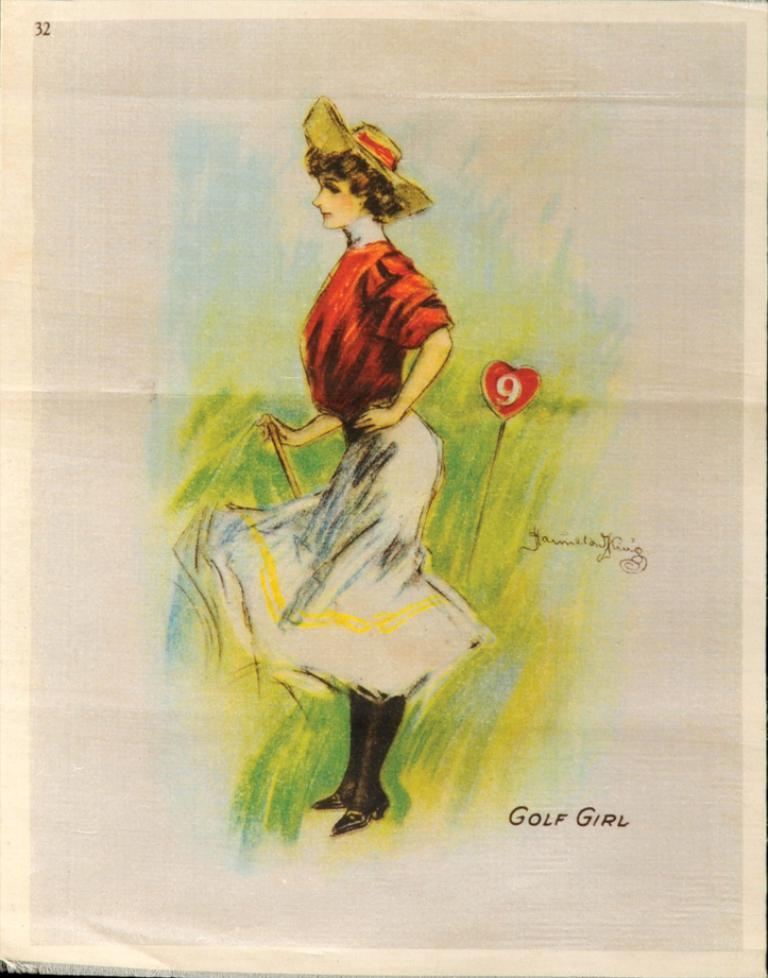What is depicted on the paper in the image? There is a painting of a person on the paper. What else can be seen on the paper besides the painting? There is writing on the paper. How many grains of rice are present in the painting of the person? There is no rice or grains present in the painting of the person; it is a depiction of a person on paper. What is the birth date of the person in the painting? The image does not provide any information about the person's birth date. 